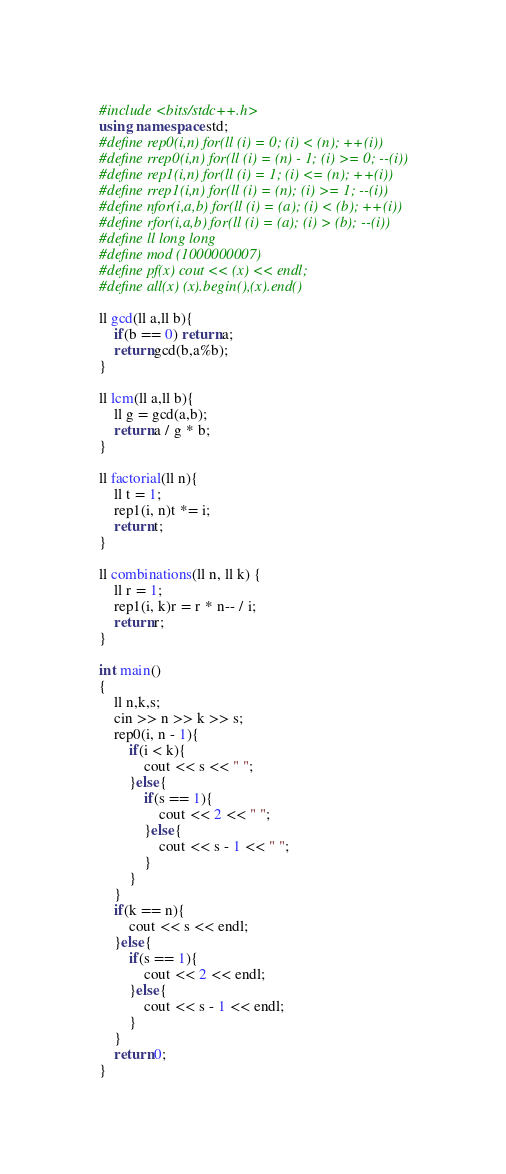<code> <loc_0><loc_0><loc_500><loc_500><_C++_>#include <bits/stdc++.h>
using namespace std;
#define rep0(i,n) for(ll (i) = 0; (i) < (n); ++(i))
#define rrep0(i,n) for(ll (i) = (n) - 1; (i) >= 0; --(i))
#define rep1(i,n) for(ll (i) = 1; (i) <= (n); ++(i))
#define rrep1(i,n) for(ll (i) = (n); (i) >= 1; --(i))
#define nfor(i,a,b) for(ll (i) = (a); (i) < (b); ++(i))
#define rfor(i,a,b) for(ll (i) = (a); (i) > (b); --(i))
#define ll long long
#define mod (1000000007)
#define pf(x) cout << (x) << endl;
#define all(x) (x).begin(),(x).end()

ll gcd(ll a,ll b){
    if(b == 0) return a;
    return gcd(b,a%b);
}

ll lcm(ll a,ll b){
    ll g = gcd(a,b);
    return a / g * b;
}

ll factorial(ll n){
    ll t = 1;
    rep1(i, n)t *= i;
    return t;
}

ll combinations(ll n, ll k) {
    ll r = 1;
    rep1(i, k)r = r * n-- / i;
    return r;
}

int main()
{
    ll n,k,s;
    cin >> n >> k >> s;
    rep0(i, n - 1){
        if(i < k){
            cout << s << " ";
        }else{
            if(s == 1){
                cout << 2 << " ";
            }else{
                cout << s - 1 << " ";
            }
        }
    }
    if(k == n){
        cout << s << endl;
    }else{
        if(s == 1){
            cout << 2 << endl;
        }else{
            cout << s - 1 << endl;
        }
    }
    return 0;
}
</code> 